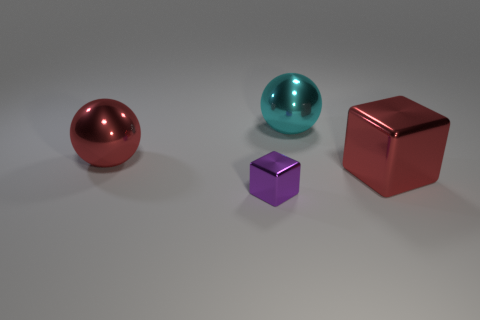Are there any other things that have the same size as the purple shiny thing?
Ensure brevity in your answer.  No. There is a object that is behind the red metal thing that is left of the cyan metal sphere; is there a big red cube that is to the left of it?
Keep it short and to the point. No. There is another big thing that is the same shape as the big cyan metallic thing; what material is it?
Offer a very short reply. Metal. Is there any other thing that has the same material as the cyan sphere?
Your response must be concise. Yes. How many spheres are either tiny things or large metallic objects?
Make the answer very short. 2. Does the red object left of the red metal cube have the same size as the cube that is right of the large cyan metal sphere?
Make the answer very short. Yes. What material is the large object that is in front of the large metallic object to the left of the cyan metal sphere made of?
Give a very brief answer. Metal. Is the number of cyan metallic objects on the left side of the big cube less than the number of big brown balls?
Ensure brevity in your answer.  No. The cyan thing that is made of the same material as the small purple block is what shape?
Provide a succinct answer. Sphere. How many other things are the same shape as the big cyan thing?
Your answer should be very brief. 1. 